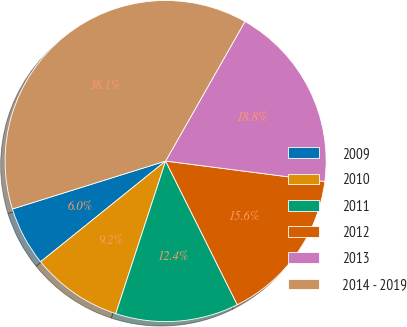Convert chart to OTSL. <chart><loc_0><loc_0><loc_500><loc_500><pie_chart><fcel>2009<fcel>2010<fcel>2011<fcel>2012<fcel>2013<fcel>2014 - 2019<nl><fcel>5.97%<fcel>9.18%<fcel>12.39%<fcel>15.6%<fcel>18.81%<fcel>38.06%<nl></chart> 